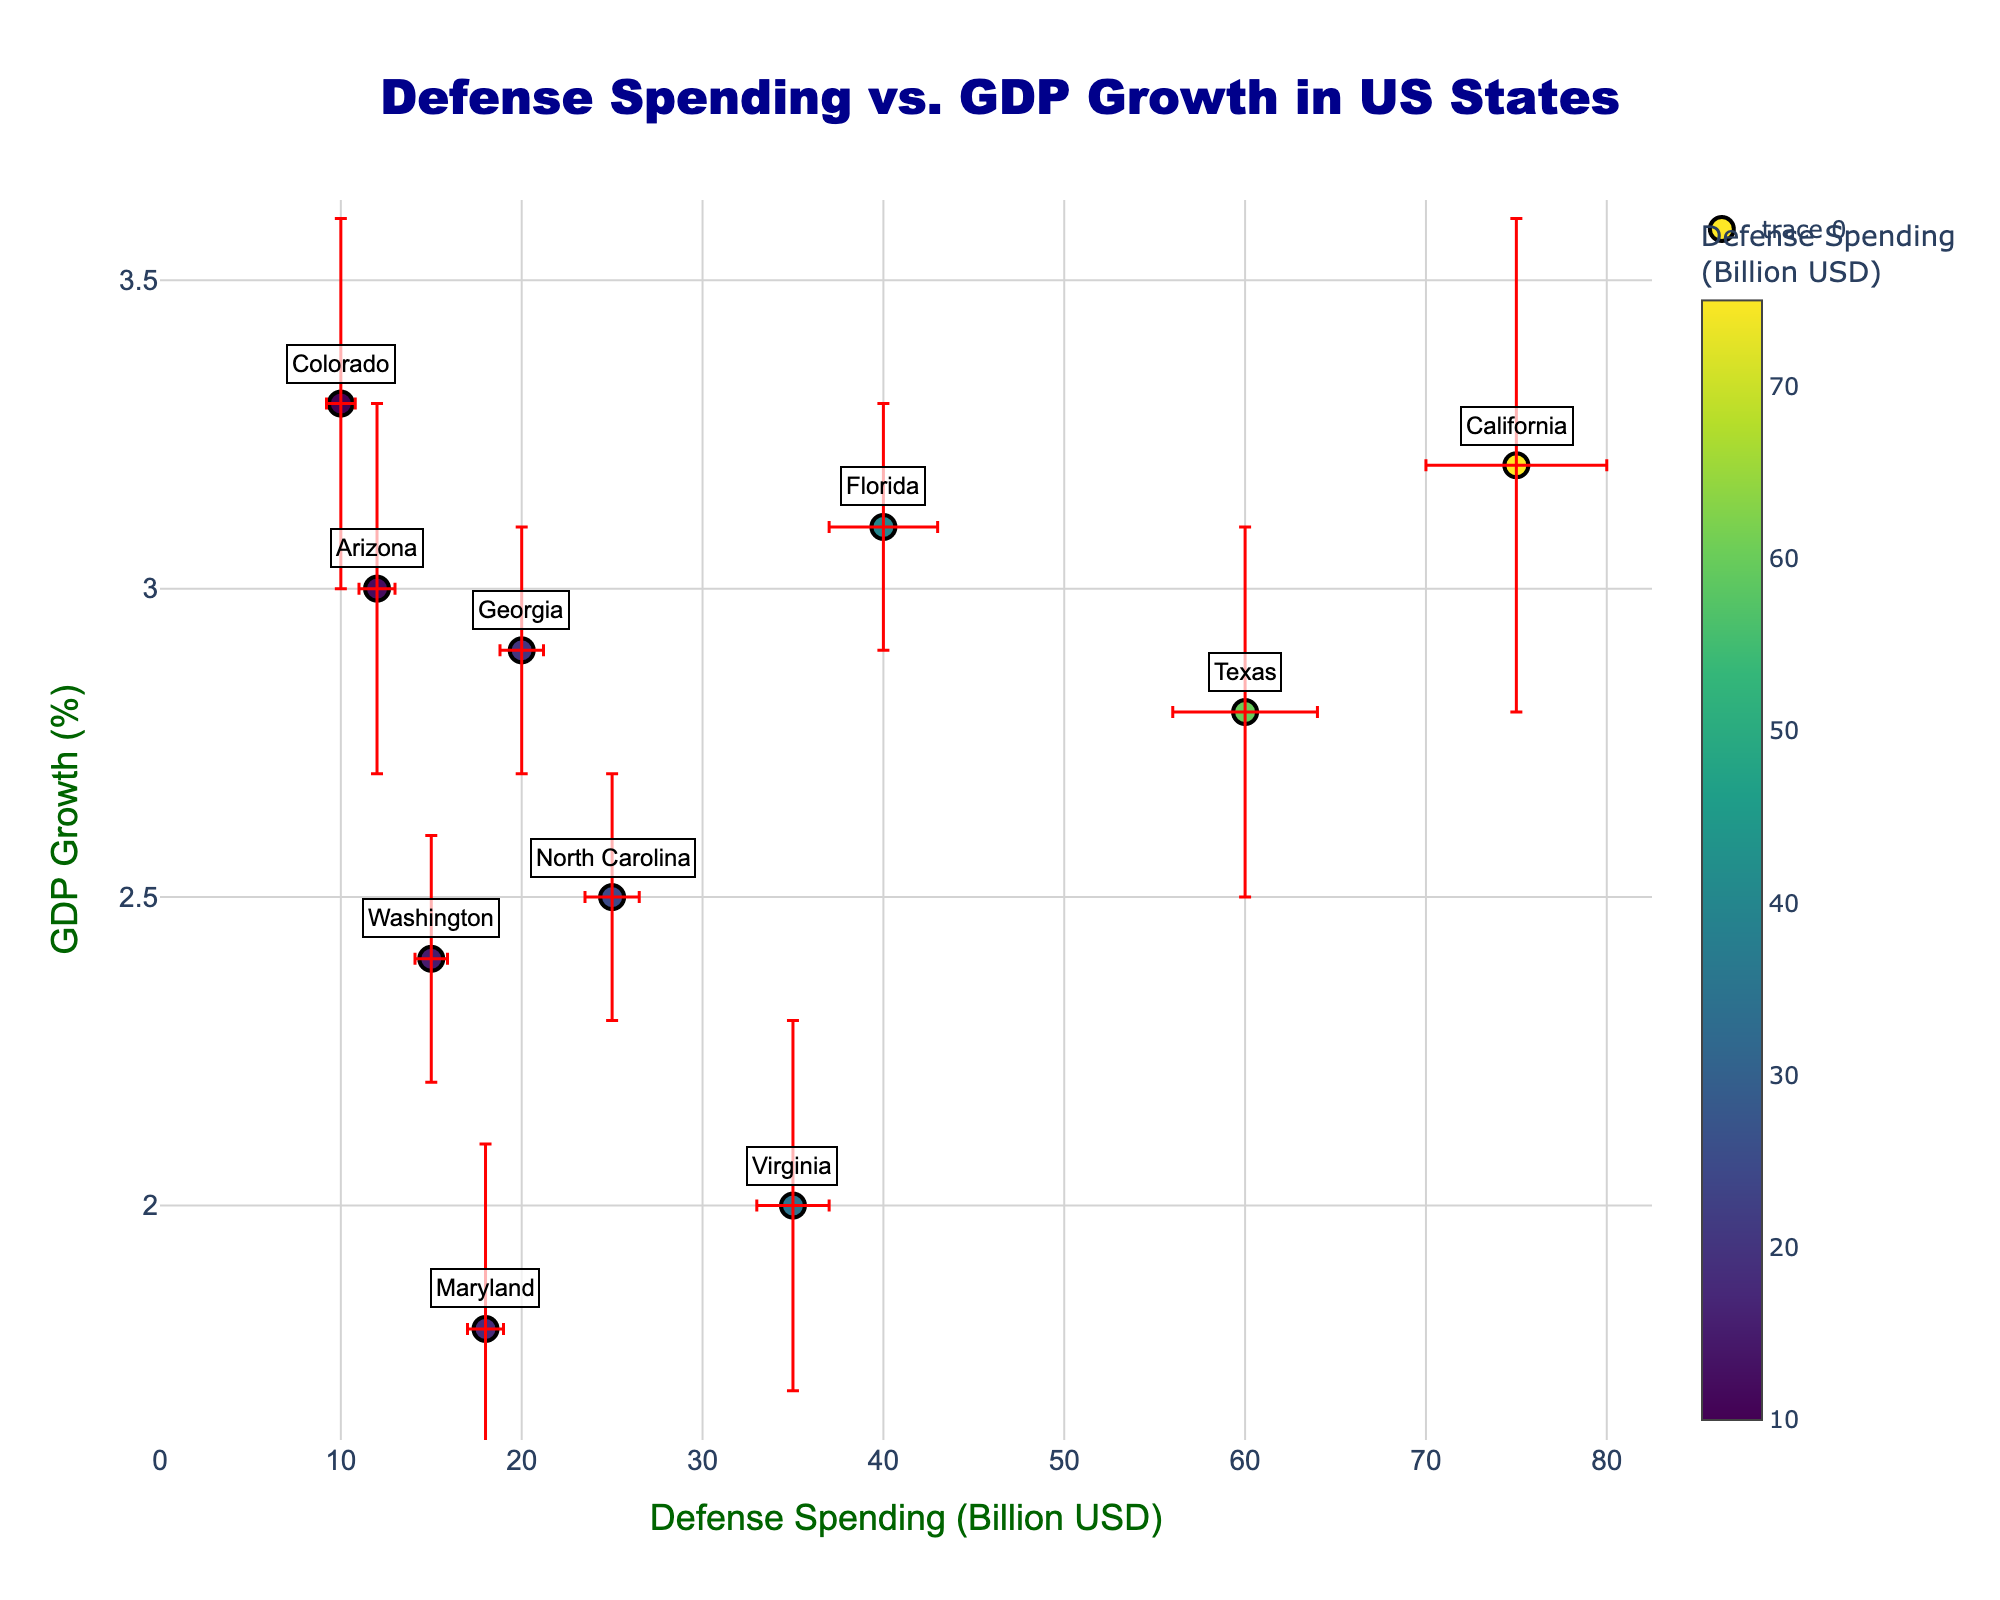What is the title of the scatter plot? The title is the text at the top of the scatter plot that describes the graph's content. The title in this scatter plot is "Defense Spending vs. GDP Growth in US States".
Answer: Defense Spending vs. GDP Growth in US States Which state has the highest defense spending? Observing the x-axis, which represents defense spending in billion USD, the point farthest to the right is California, indicating it has the highest defense spending.
Answer: California What is the approximate GDP growth rate for Florida? Locate the point labeled "Florida" and check its position on the y-axis, which shows GDP growth in percentage. Florida is around 3.1%.
Answer: 3.1% What is the average GDP growth rate of Virginia and Texas? Virginia has a GDP growth rate of 2.0%, and Texas has 2.8%. Add these rates and divide by 2 to find the average. (2.0 + 2.8) / 2 = 2.4%
Answer: 2.4% Which state has the highest error bar in defense spending? The length of the error bar parallel to the x-axis (defense spending) must be checked. California, with an error of 5 billion USD, has the longest error bar.
Answer: California Between Georgia and Washington, which state has a higher GDP growth rate? Compare the y-axis positions of the points labeled Georgia and Washington. Georgia's GDP growth of 2.9% is higher than Washington's 2.4%.
Answer: Georgia Is there a general trend between defense spending and GDP growth in the plot? Observing the plot, there is no clear increasing or decreasing trend between defense spending and GDP growth; states with high and low values in either category appear scattered.
Answer: No clear trend Which states have a defense spending error bar less than 1 billion USD? The states with error bars shorter than 1 billion USD are those with small error intervals on the x-axis. North Carolina (1.5 billion) does not qualify, leaving Maryland (1 billion), Washington (0.9 billion), Arizona (1 billion), and Colorado (0.8 billion) as candidates. However, only Washington and Colorado have errors less than 1 billion.
Answer: Washington, Colorado What is the total defense spending for California and Texas? Sum the two states' defense spending: California (75 billion USD) and Texas (60 billion USD). 75 + 60 = 135 billion USD.
Answer: 135 billion USD 